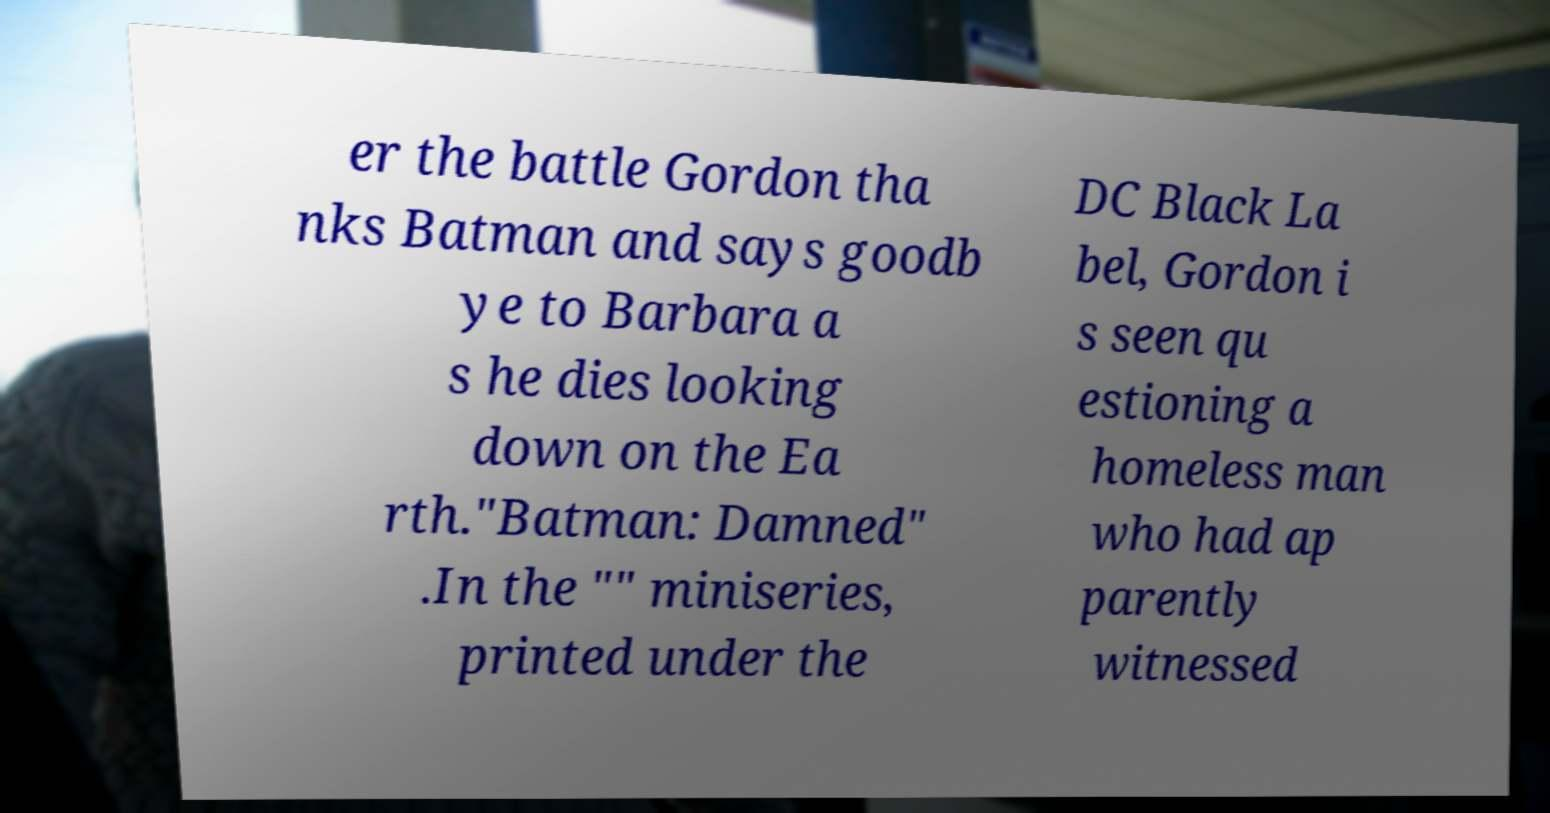Can you accurately transcribe the text from the provided image for me? er the battle Gordon tha nks Batman and says goodb ye to Barbara a s he dies looking down on the Ea rth."Batman: Damned" .In the "" miniseries, printed under the DC Black La bel, Gordon i s seen qu estioning a homeless man who had ap parently witnessed 